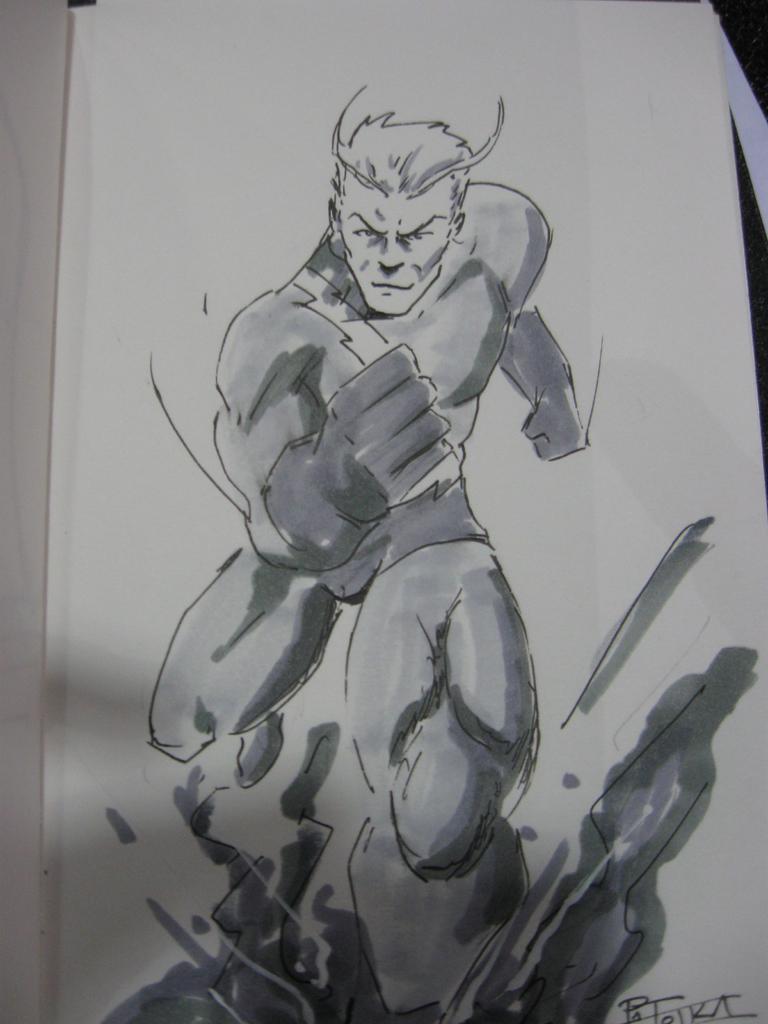In one or two sentences, can you explain what this image depicts? In this picture I can see the diagram of a person. 